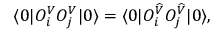Convert formula to latex. <formula><loc_0><loc_0><loc_500><loc_500>\langle 0 | O _ { i } ^ { V } O _ { j } ^ { V } | 0 \rangle = \langle 0 | O _ { i } ^ { \widehat { V } } O _ { j } ^ { \widehat { V } } | 0 \rangle ,</formula> 